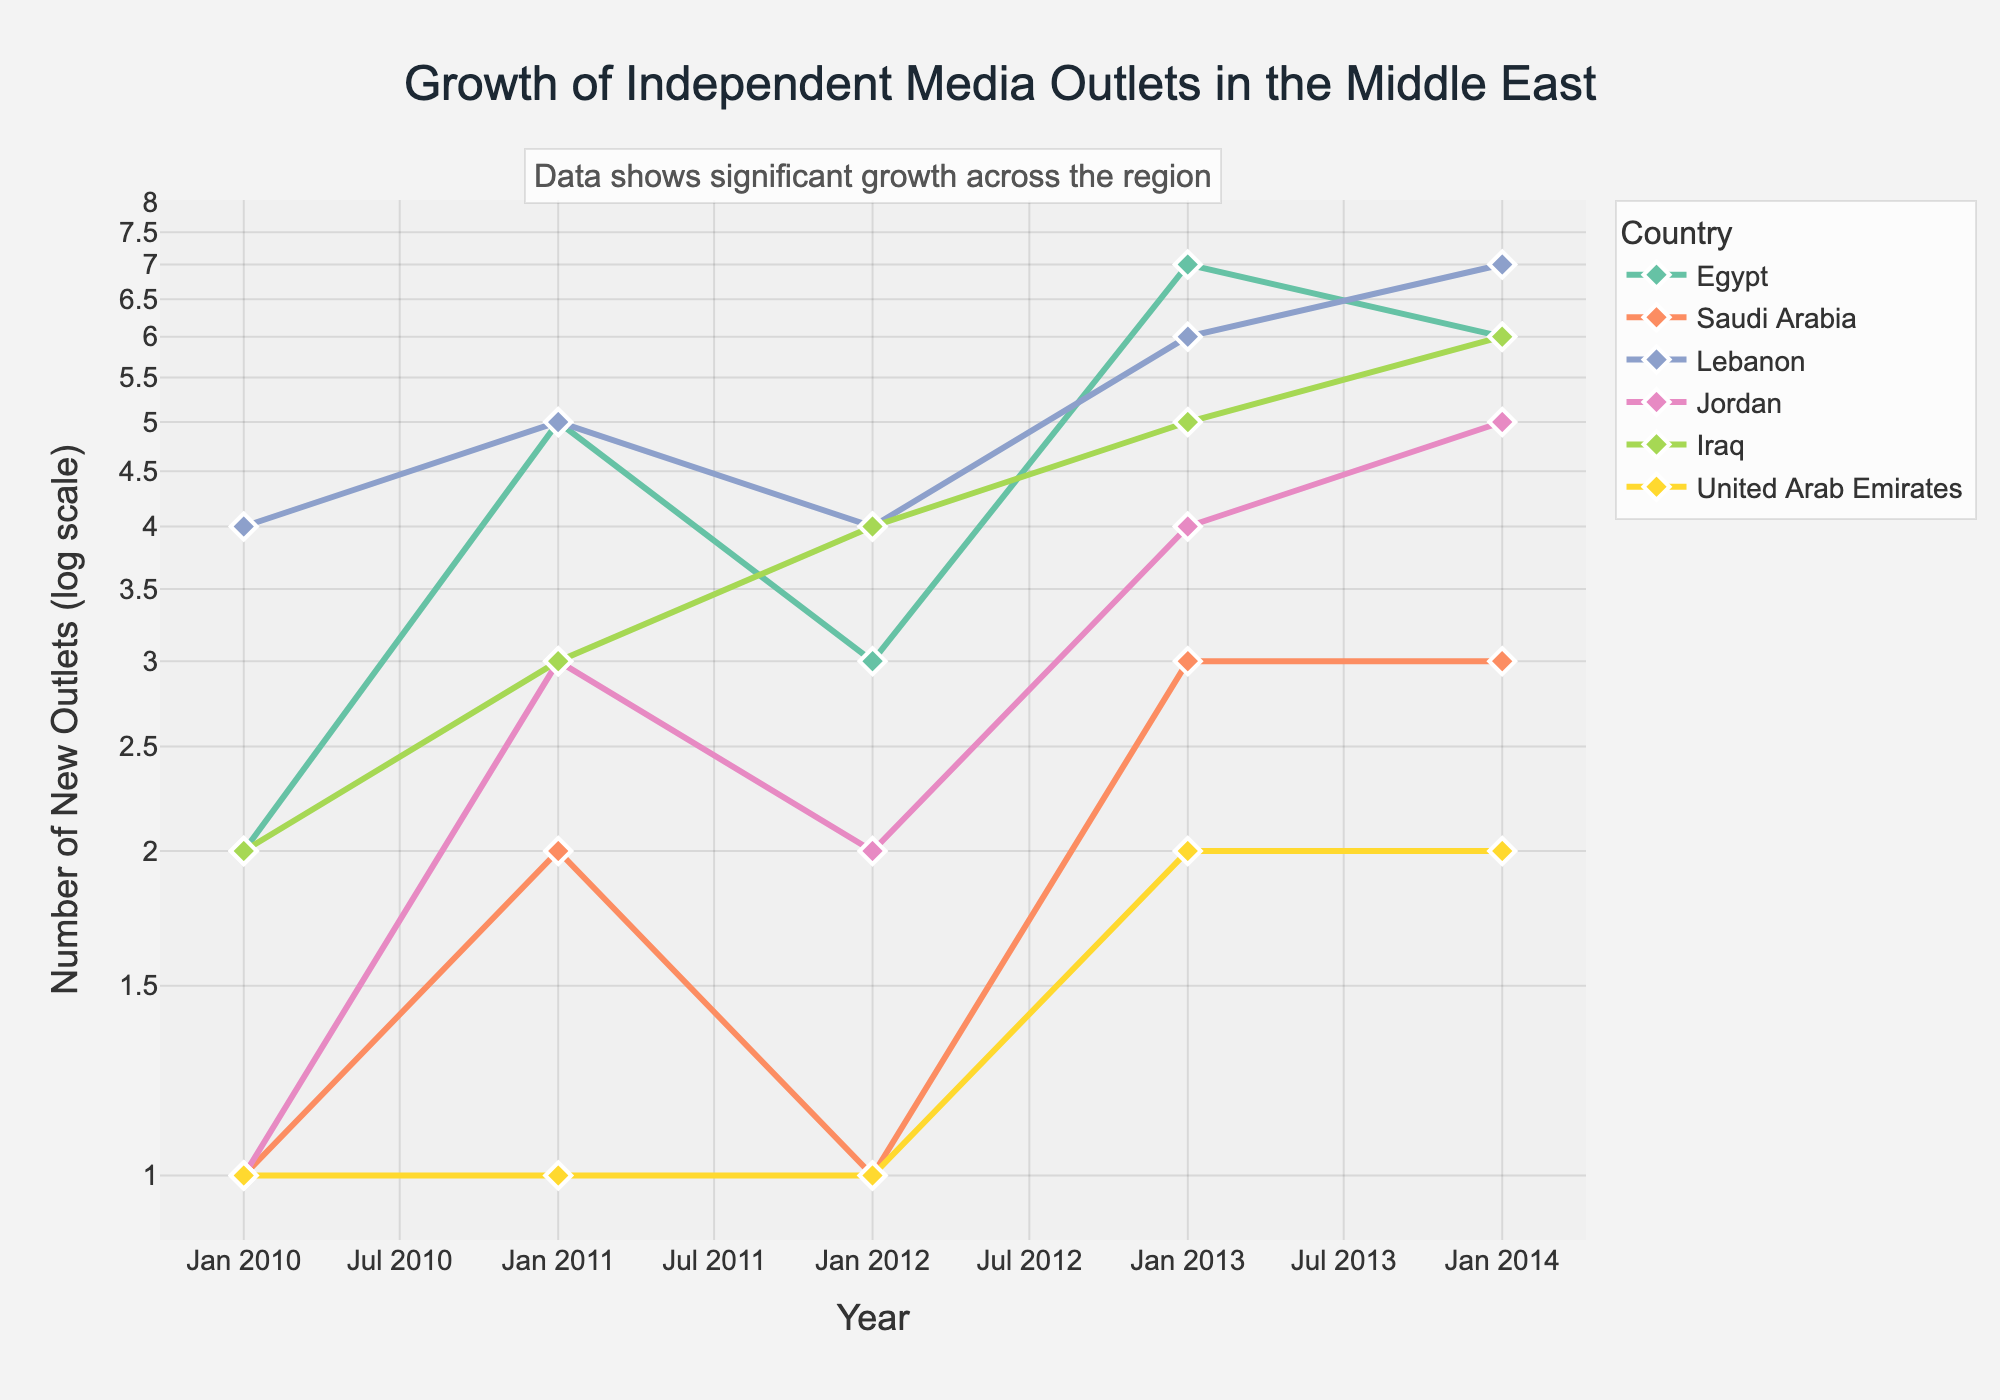what is the title of the figure? The title of the figure is shown at the top, centered, and in a larger font size compared to other text elements.
Answer: Growth of Independent Media Outlets in the Middle East Which country's independent media outlets experienced the most substantial growth between 2010 and 2014? By visually inspecting the different lines, Lebanon shows the highest increase in the number of new outlets, from 4 in 2010 to 7 in 2014.
Answer: Lebanon What do the log scale y-axis values represent in the figure? The log scale y-axis indicates the number of new media outlets, represented in a logarithmic scale to better visualize differences when values vary significantly. Each increment represents a multiplicative increase.
Answer: Number of new outlets Compare the number of new media outlets between Egypt and Saudi Arabia in 2013. The figure shows that in 2013, Egypt had 7 new outlets and Saudi Arabia had 3. By visual comparison on the y-axis, we can determine this difference.
Answer: Egypt had 4 more outlets than Saudi Arabia Which country had the least number of new media outlets consistently from 2010 to 2014? By examining the lines for each country over the years, the United Arab Emirates consistently has the lowest numbers, fluctuating between 1 and 2 new outlets each year.
Answer: United Arab Emirates Discuss the trend of new media outlets in Iraq from 2010 to 2014. The figure shows a steady increase in Iraq's line, with new outlets growing from 2 in 2010 to 6 in 2014. This indicates consistent growth year over year.
Answer: Steady increase from 2 to 6 How many countries had 5 new media outlets in 2014? By checking the y-axis values for each country’s line, we see that in 2014, Jordan and Iraq each had 5 new media outlets.
Answer: 2 (Jordan and Iraq) Compare the growth trends between Egypt and Lebanon from 2010 to 2014. Egypt's line shows more fluctuations, peaking in 2013 at 7. In contrast, Lebanon shows a more consistent upward trend, starting at 4 in 2010 and peaking at 7 in 2014.
Answer: Lebanon has a more consistent upward trend; Egypt is more fluctuating What annotation is added to the plot, and why does it matter? The annotation at the top of the plot reads, "Data shows significant growth across the region," which highlights the overall trend of increasing new media outlets in all countries shown.
Answer: "Data shows significant growth across the region" emphasizes the overall positive trend Why is a log scale used for the y-axis in this plot? A log scale is used to better visualize the variation in data when the range of values is large. It helps to show the rate of growth across different countries more clearly, making it easier to compare them.
Answer: To better visualize variations and growth rates across different countries 